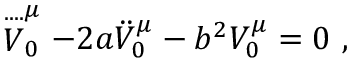Convert formula to latex. <formula><loc_0><loc_0><loc_500><loc_500>\stackrel { \cdots } V _ { 0 } ^ { \mu } - 2 a \ddot { V } _ { 0 } ^ { \mu } - b ^ { 2 } V _ { 0 } ^ { \mu } = 0 ,</formula> 